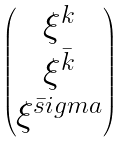Convert formula to latex. <formula><loc_0><loc_0><loc_500><loc_500>\begin{pmatrix} \xi ^ { k } \\ \xi ^ { \bar { k } } \\ \xi ^ { \bar { s } i g m a } \end{pmatrix}</formula> 